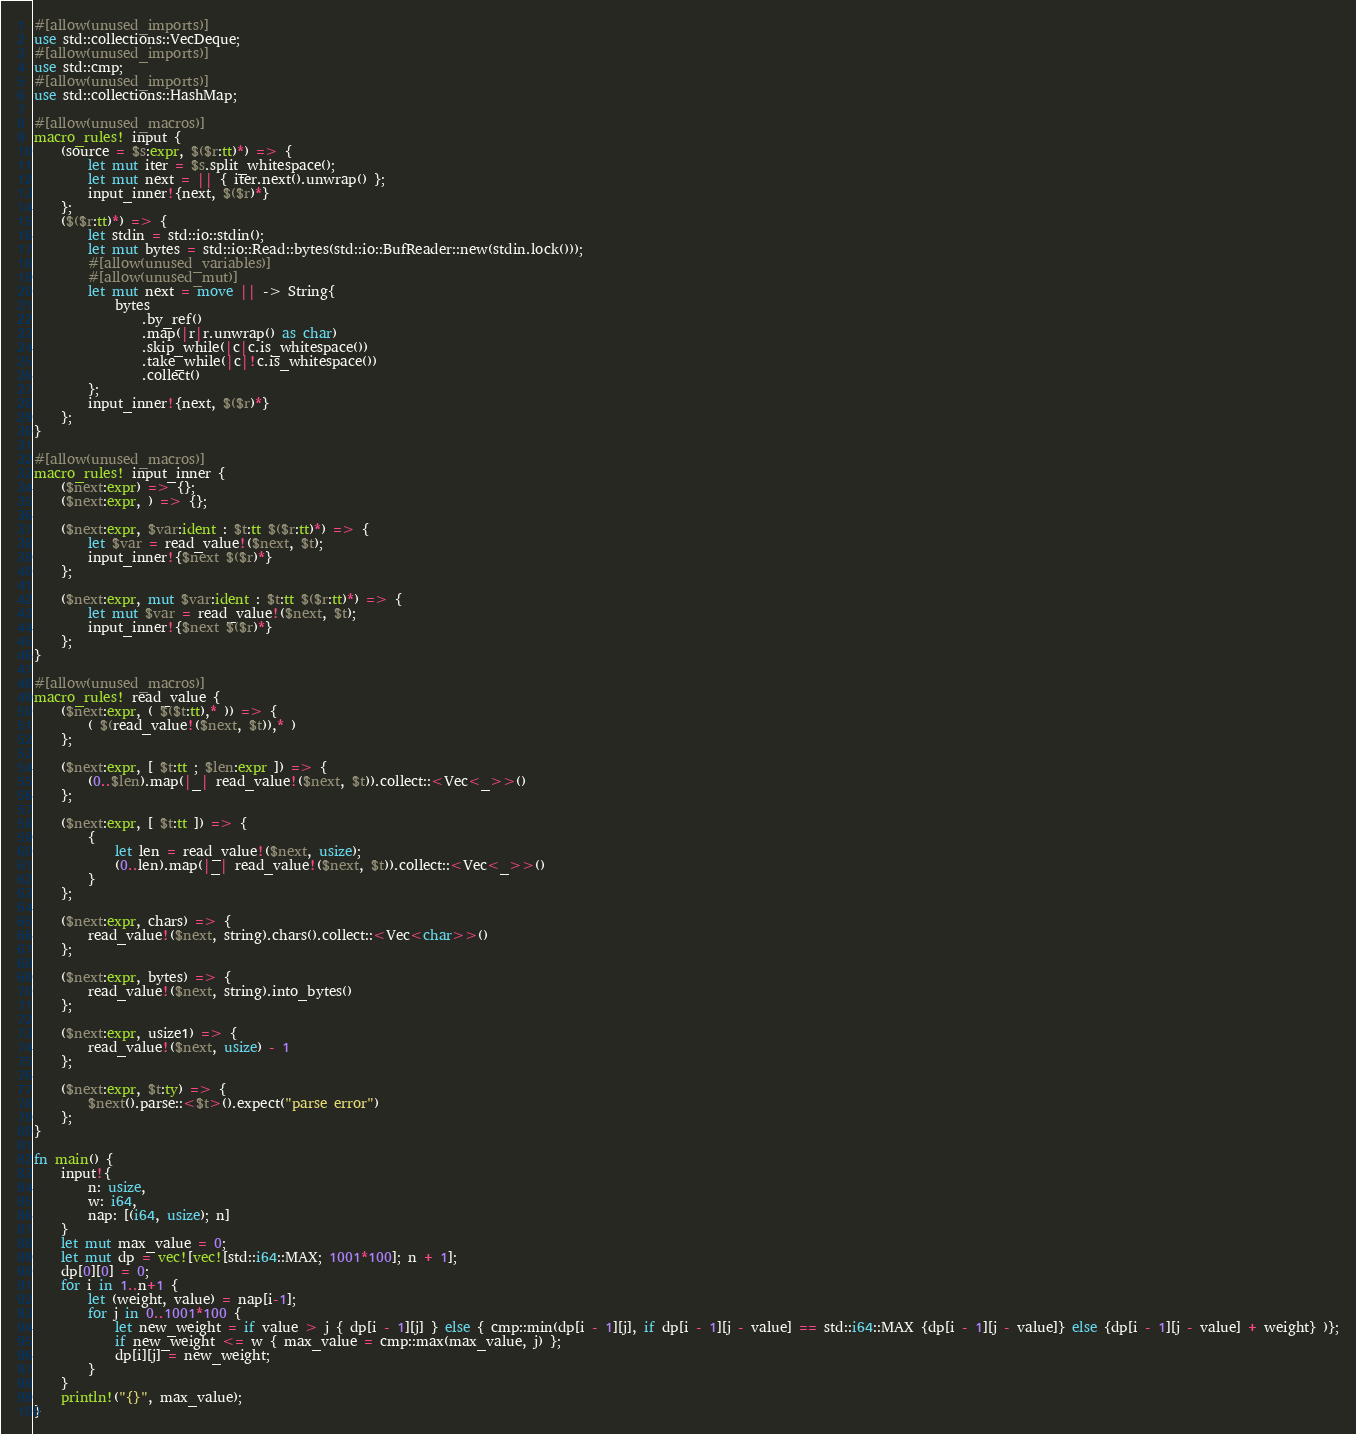<code> <loc_0><loc_0><loc_500><loc_500><_Rust_>#[allow(unused_imports)]
use std::collections::VecDeque;
#[allow(unused_imports)]
use std::cmp;
#[allow(unused_imports)]
use std::collections::HashMap;

#[allow(unused_macros)]
macro_rules! input {
    (source = $s:expr, $($r:tt)*) => {
        let mut iter = $s.split_whitespace();
        let mut next = || { iter.next().unwrap() };
        input_inner!{next, $($r)*}
    };
    ($($r:tt)*) => {
        let stdin = std::io::stdin();
        let mut bytes = std::io::Read::bytes(std::io::BufReader::new(stdin.lock()));
        #[allow(unused_variables)]
        #[allow(unused_mut)]
        let mut next = move || -> String{
            bytes
                .by_ref()
                .map(|r|r.unwrap() as char)
                .skip_while(|c|c.is_whitespace())
                .take_while(|c|!c.is_whitespace())
                .collect()
        };
        input_inner!{next, $($r)*}
    };
}

#[allow(unused_macros)]
macro_rules! input_inner {
    ($next:expr) => {};
    ($next:expr, ) => {};

    ($next:expr, $var:ident : $t:tt $($r:tt)*) => {
        let $var = read_value!($next, $t);
        input_inner!{$next $($r)*}
    };
 
    ($next:expr, mut $var:ident : $t:tt $($r:tt)*) => {
        let mut $var = read_value!($next, $t);
        input_inner!{$next $($r)*}
    };
}

#[allow(unused_macros)]
macro_rules! read_value {
    ($next:expr, ( $($t:tt),* )) => {
        ( $(read_value!($next, $t)),* )
    };

    ($next:expr, [ $t:tt ; $len:expr ]) => {
        (0..$len).map(|_| read_value!($next, $t)).collect::<Vec<_>>()
    };
 
    ($next:expr, [ $t:tt ]) => {
        {
            let len = read_value!($next, usize);
            (0..len).map(|_| read_value!($next, $t)).collect::<Vec<_>>()
        }
    };
 
    ($next:expr, chars) => {
        read_value!($next, string).chars().collect::<Vec<char>>()
    };
 
    ($next:expr, bytes) => {
        read_value!($next, string).into_bytes()
    };
 
    ($next:expr, usize1) => {
        read_value!($next, usize) - 1
    };
 
    ($next:expr, $t:ty) => {
        $next().parse::<$t>().expect("parse error")
    };
}

fn main() {
    input!{
        n: usize,
        w: i64,
        nap: [(i64, usize); n]
    }
    let mut max_value = 0;
    let mut dp = vec![vec![std::i64::MAX; 1001*100]; n + 1];
    dp[0][0] = 0;
    for i in 1..n+1 {
        let (weight, value) = nap[i-1];
        for j in 0..1001*100 {
            let new_weight = if value > j { dp[i - 1][j] } else { cmp::min(dp[i - 1][j], if dp[i - 1][j - value] == std::i64::MAX {dp[i - 1][j - value]} else {dp[i - 1][j - value] + weight} )};
            if new_weight <= w { max_value = cmp::max(max_value, j) };
            dp[i][j] = new_weight;
        }
    }
    println!("{}", max_value);
}
</code> 